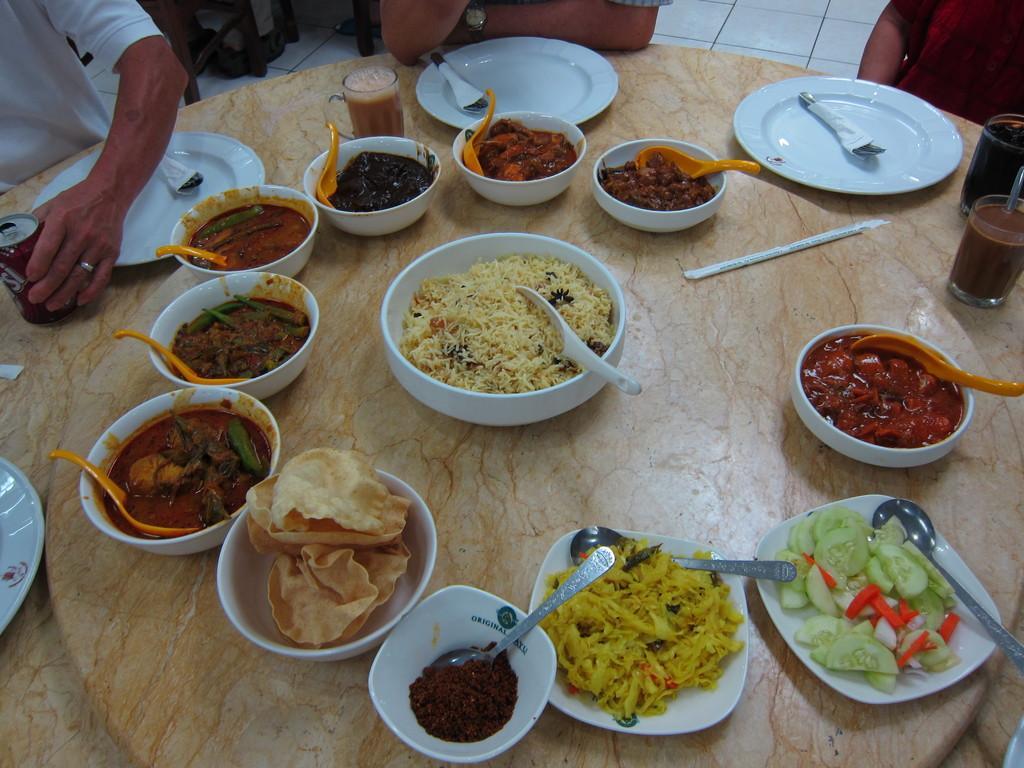Could you give a brief overview of what you see in this image? In this image we can see the food items placed in the bowls, plates and also cups. We can also see the spoons, glasses and also the empty plates with the tissue and spoon. There is also a tin and two persons sitting. There is also another person sitting in front of the table. Floor is also visible. 